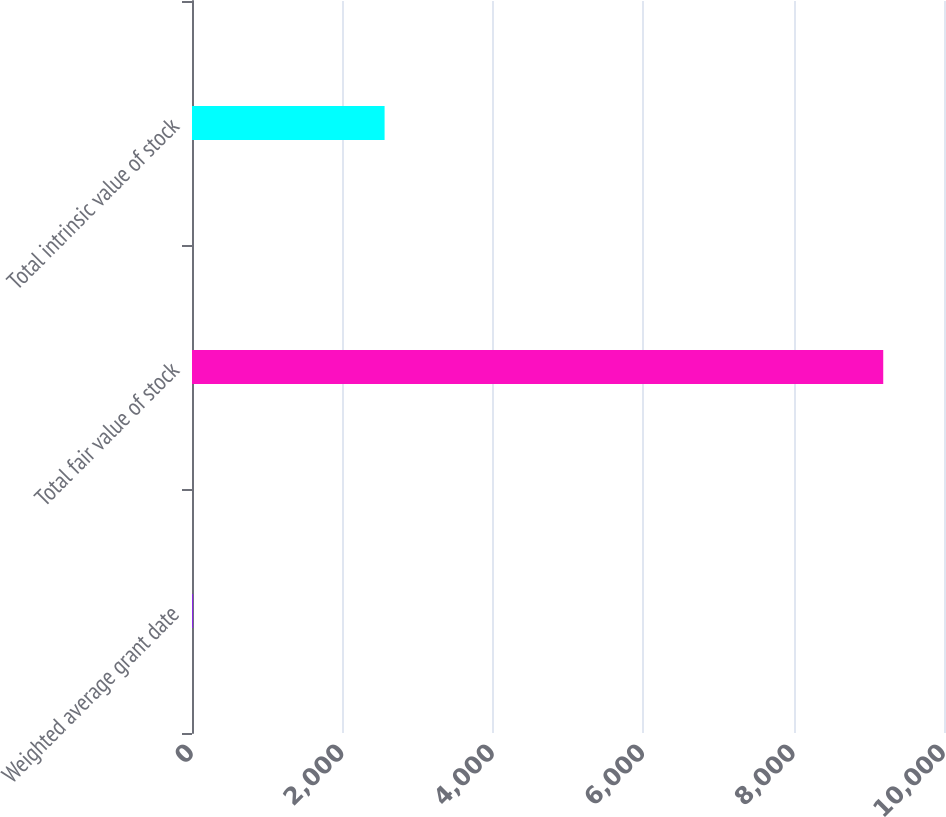Convert chart. <chart><loc_0><loc_0><loc_500><loc_500><bar_chart><fcel>Weighted average grant date<fcel>Total fair value of stock<fcel>Total intrinsic value of stock<nl><fcel>14.54<fcel>9192<fcel>2561<nl></chart> 